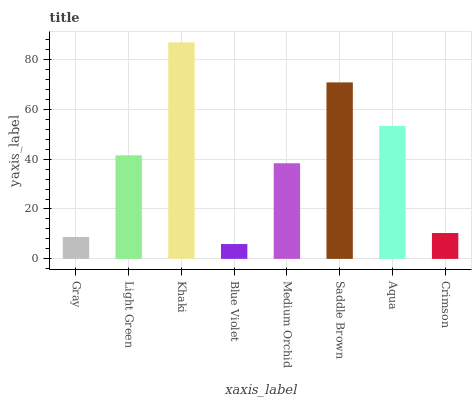Is Blue Violet the minimum?
Answer yes or no. Yes. Is Khaki the maximum?
Answer yes or no. Yes. Is Light Green the minimum?
Answer yes or no. No. Is Light Green the maximum?
Answer yes or no. No. Is Light Green greater than Gray?
Answer yes or no. Yes. Is Gray less than Light Green?
Answer yes or no. Yes. Is Gray greater than Light Green?
Answer yes or no. No. Is Light Green less than Gray?
Answer yes or no. No. Is Light Green the high median?
Answer yes or no. Yes. Is Medium Orchid the low median?
Answer yes or no. Yes. Is Medium Orchid the high median?
Answer yes or no. No. Is Crimson the low median?
Answer yes or no. No. 